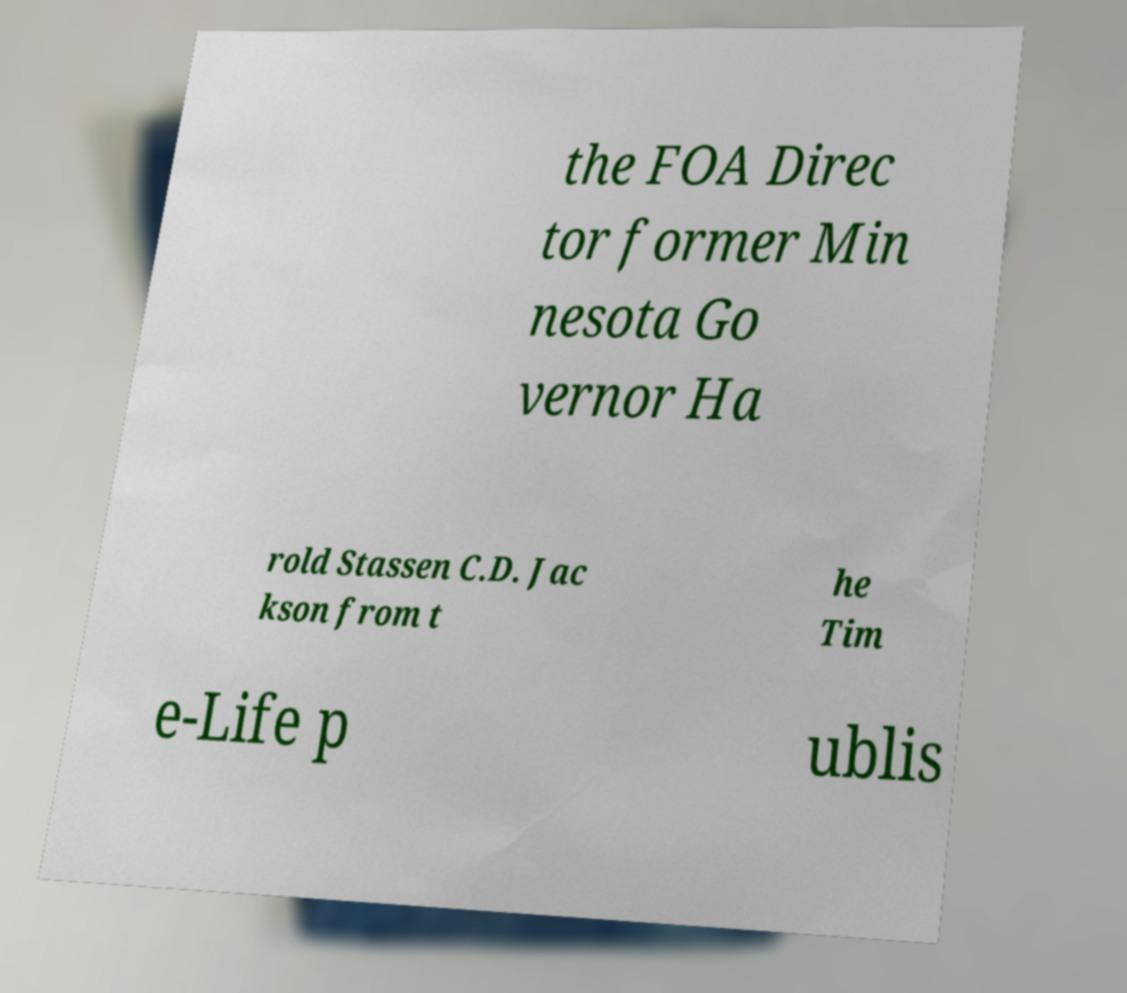What messages or text are displayed in this image? I need them in a readable, typed format. the FOA Direc tor former Min nesota Go vernor Ha rold Stassen C.D. Jac kson from t he Tim e-Life p ublis 